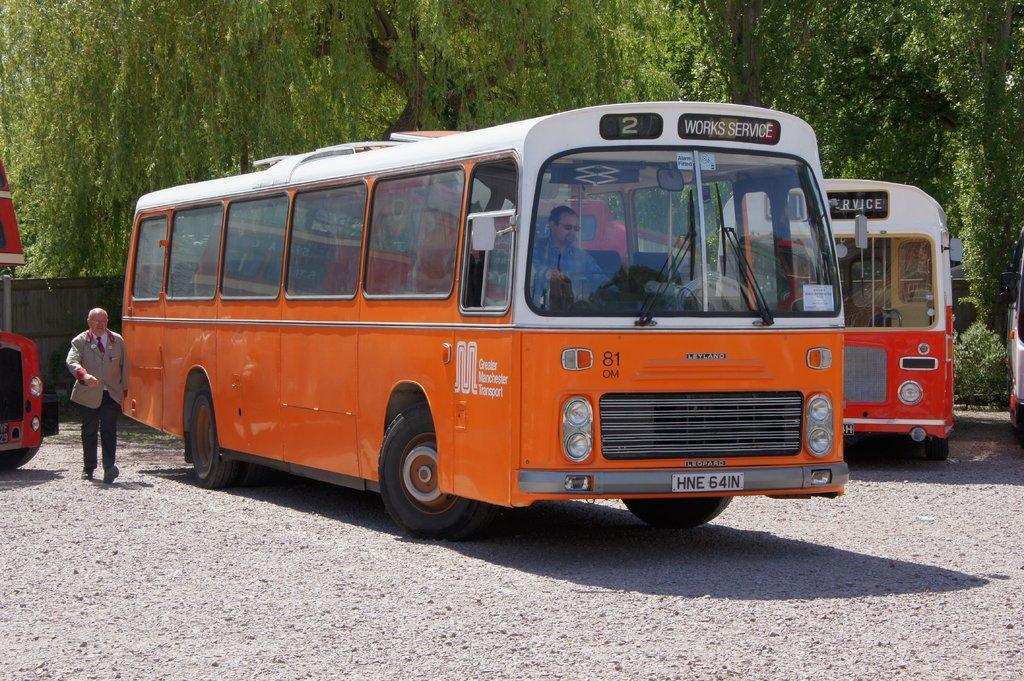<image>
Present a compact description of the photo's key features. An orange bus with the sign Works Service for Greater Manchester Transport. 